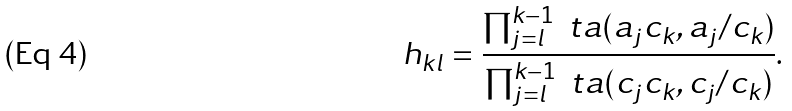<formula> <loc_0><loc_0><loc_500><loc_500>h _ { k l } = \frac { \prod _ { j = l } ^ { k - 1 } \ t a ( a _ { j } c _ { k } , a _ { j } / c _ { k } ) } { \prod _ { j = l } ^ { k - 1 } \ t a ( c _ { j } c _ { k } , c _ { j } / c _ { k } ) } .</formula> 